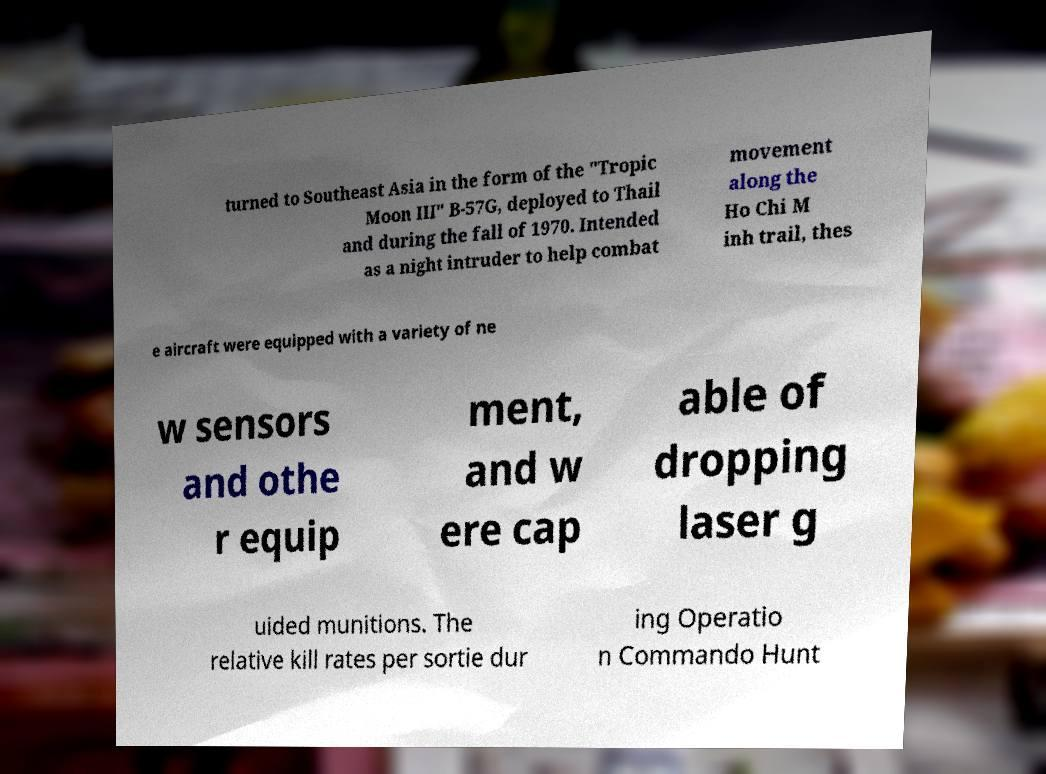Can you accurately transcribe the text from the provided image for me? turned to Southeast Asia in the form of the "Tropic Moon III" B-57G, deployed to Thail and during the fall of 1970. Intended as a night intruder to help combat movement along the Ho Chi M inh trail, thes e aircraft were equipped with a variety of ne w sensors and othe r equip ment, and w ere cap able of dropping laser g uided munitions. The relative kill rates per sortie dur ing Operatio n Commando Hunt 